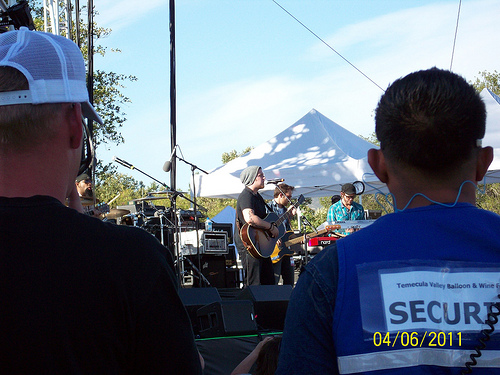<image>
Is the man in front of the guitar? No. The man is not in front of the guitar. The spatial positioning shows a different relationship between these objects. 